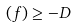Convert formula to latex. <formula><loc_0><loc_0><loc_500><loc_500>( f ) \geq - D</formula> 